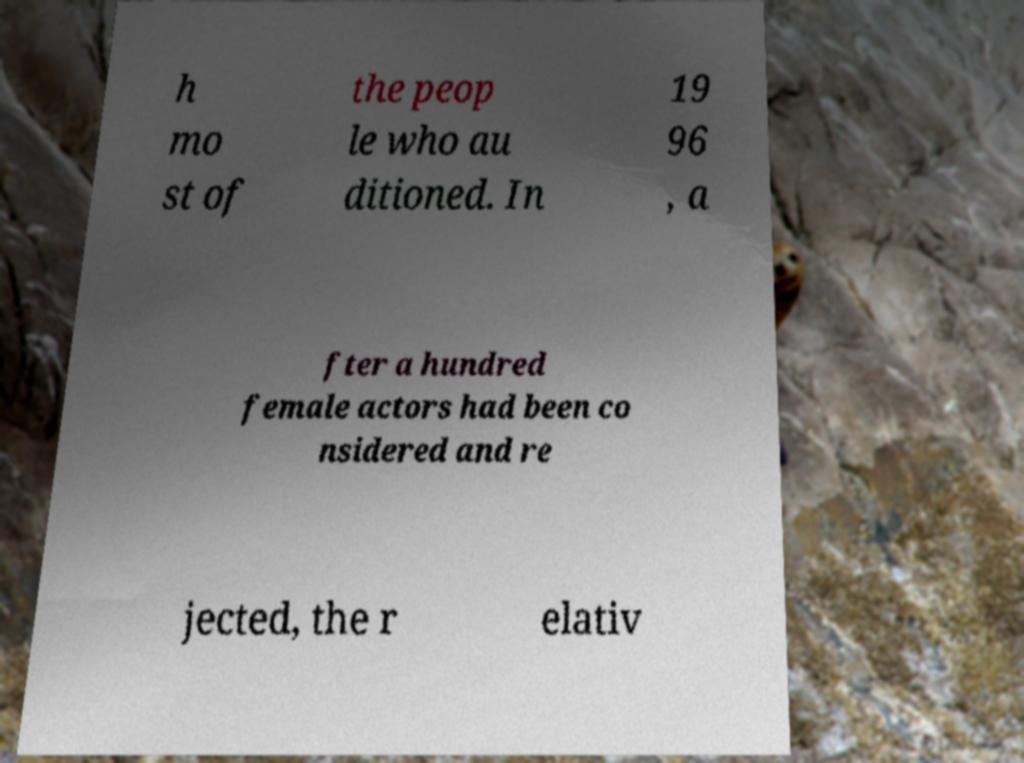There's text embedded in this image that I need extracted. Can you transcribe it verbatim? h mo st of the peop le who au ditioned. In 19 96 , a fter a hundred female actors had been co nsidered and re jected, the r elativ 